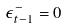<formula> <loc_0><loc_0><loc_500><loc_500>\epsilon _ { t - 1 } ^ { - } = 0</formula> 